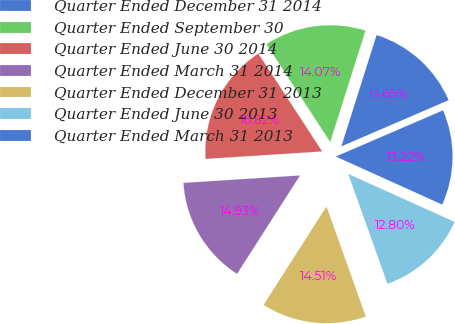Convert chart. <chart><loc_0><loc_0><loc_500><loc_500><pie_chart><fcel>Quarter Ended December 31 2014<fcel>Quarter Ended September 30<fcel>Quarter Ended June 30 2014<fcel>Quarter Ended March 31 2014<fcel>Quarter Ended December 31 2013<fcel>Quarter Ended June 30 2013<fcel>Quarter Ended March 31 2013<nl><fcel>13.65%<fcel>14.07%<fcel>16.82%<fcel>14.93%<fcel>14.51%<fcel>12.8%<fcel>13.22%<nl></chart> 